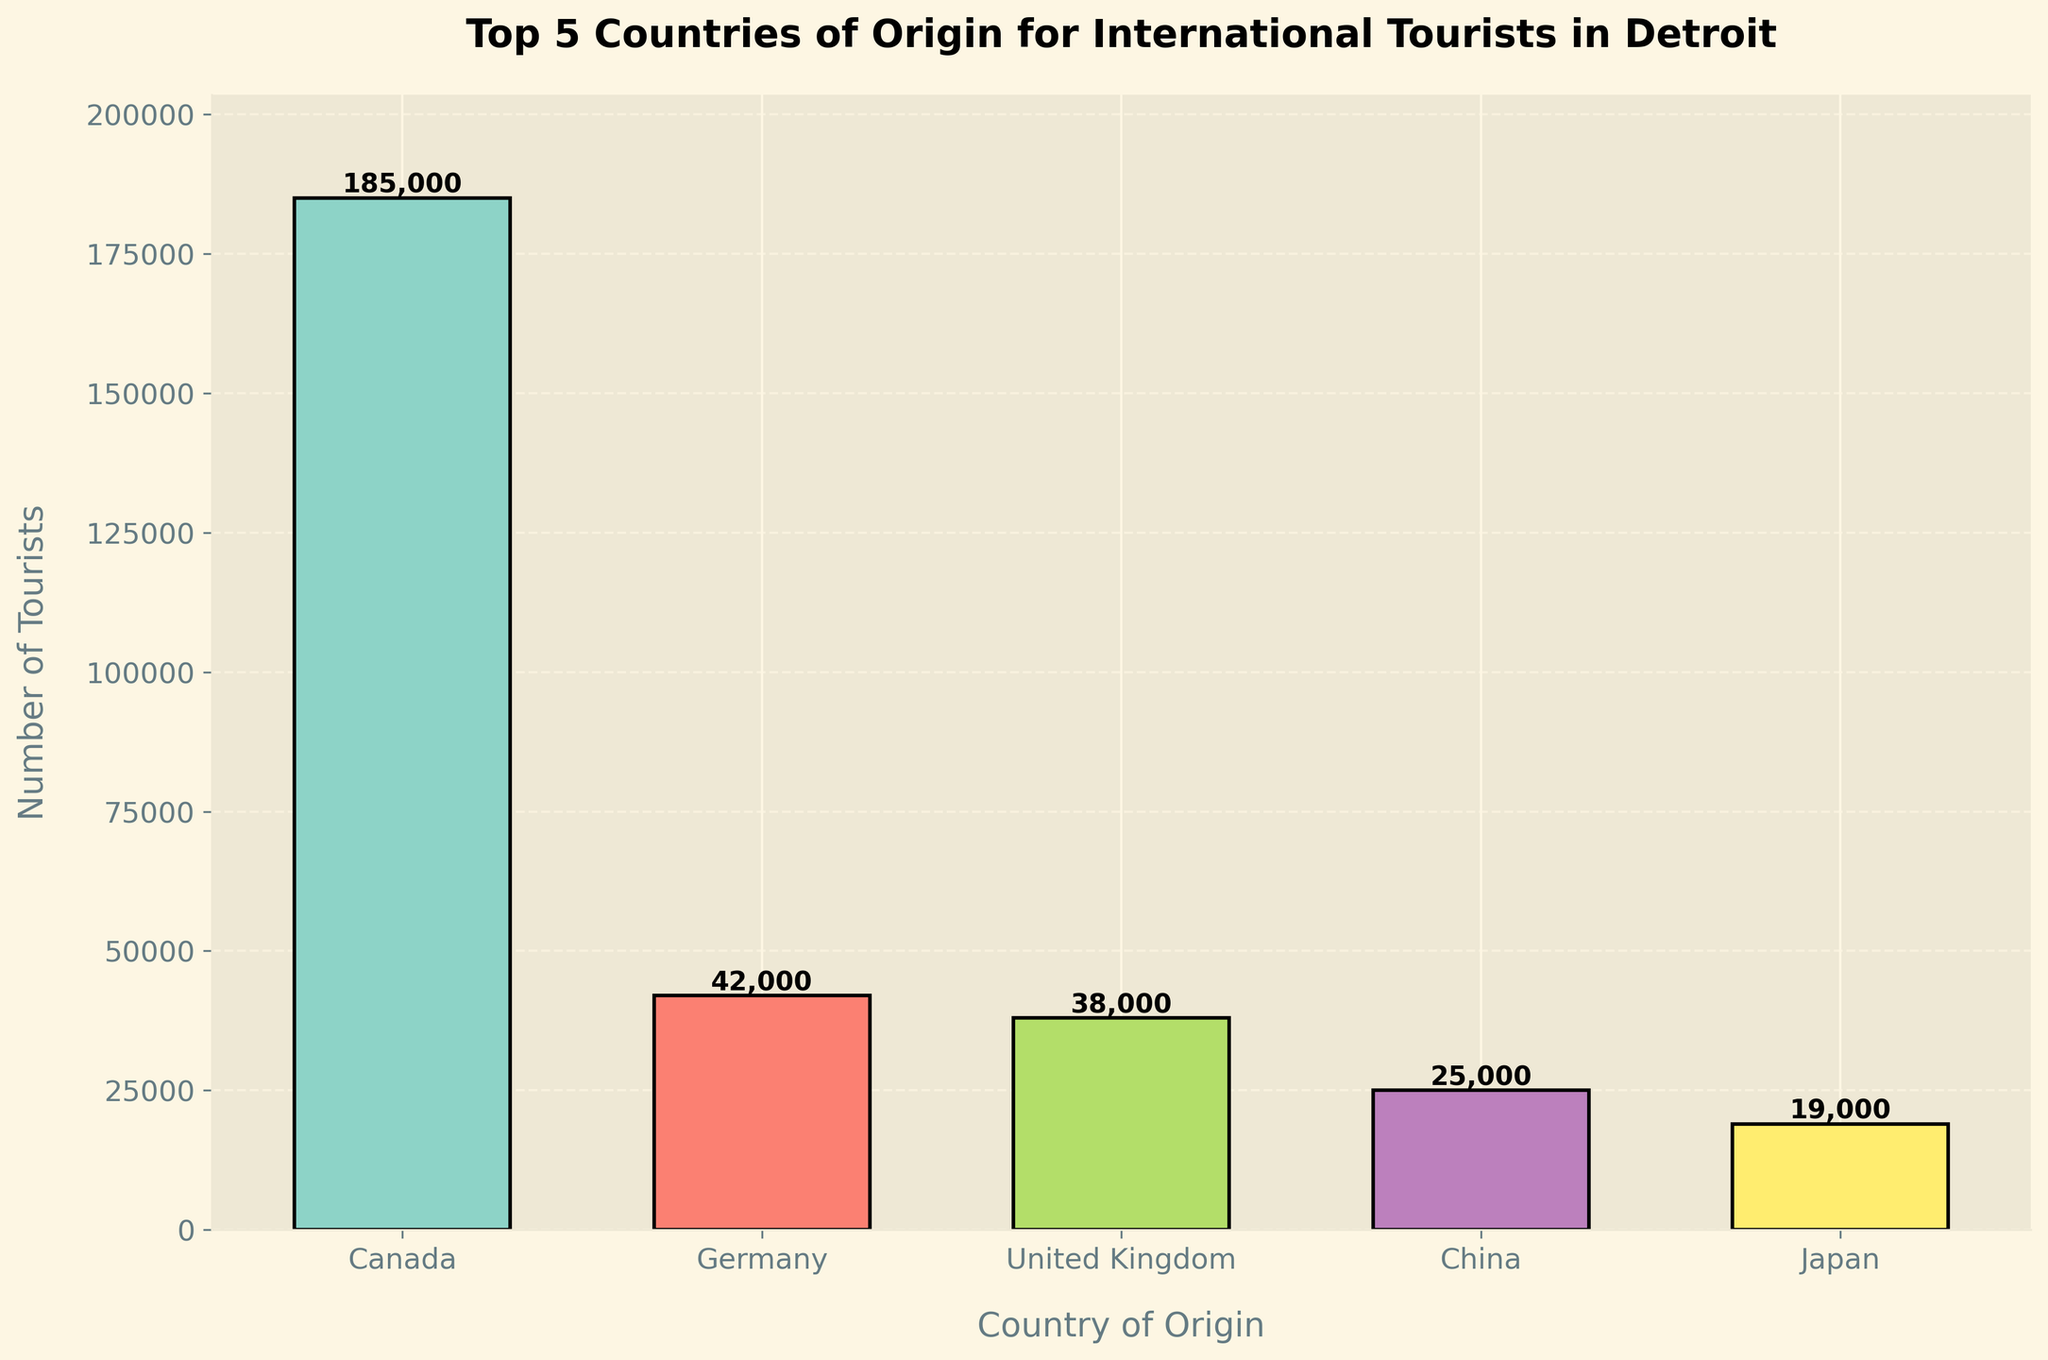Which country has the highest number of tourists visiting Detroit? The tallest bar represents the country with the highest number of tourists. Canada has the tallest bar.
Answer: Canada Which country has the lowest number of tourists visiting Detroit? The shortest bar represents the country with the lowest number of tourists. Japan has the shortest bar.
Answer: Japan How many more tourists come from Canada compared to the United Kingdom? The number of tourists from Canada is 185,000, and from the UK is 38,000. The difference is 185,000 - 38,000.
Answer: 147,000 What is the combined number of tourists from Germany and China? The number of tourists from Germany is 42,000, and from China is 25,000. The sum is 42,000 + 25,000.
Answer: 67,000 Which two countries have a combined number of tourists that exceed 60,000 but do not include Canada? By checking pairs: 
Germany (42,000) + UK (38,000) = 80,000
Germany (42,000) + China (25,000) = 67,000
UK (38,000) + China (25,000) = 63,000
All these pairs have a combined number exceeding 60,000.
Answer: Germany and UK (or Germany and China, or UK and China) How much higher is the number of tourists from Germany compared to Japan? The number of tourists from Germany is 42,000, and from Japan is 19,000. The difference is 42,000 - 19,000.
Answer: 23,000 What is the average number of tourists from the top 5 countries? The total number of tourists from all five countries is 185,000 + 42,000 + 38,000 + 25,000 + 19,000 = 309,000. There are 5 countries, so the average is 309,000 / 5.
Answer: 61,800 Which country has a number of tourists closest to the average number of tourists from the top 5 countries? The average number of tourists is 61,800. The country closest to this number is Germany with 42,000.
Answer: Germany 